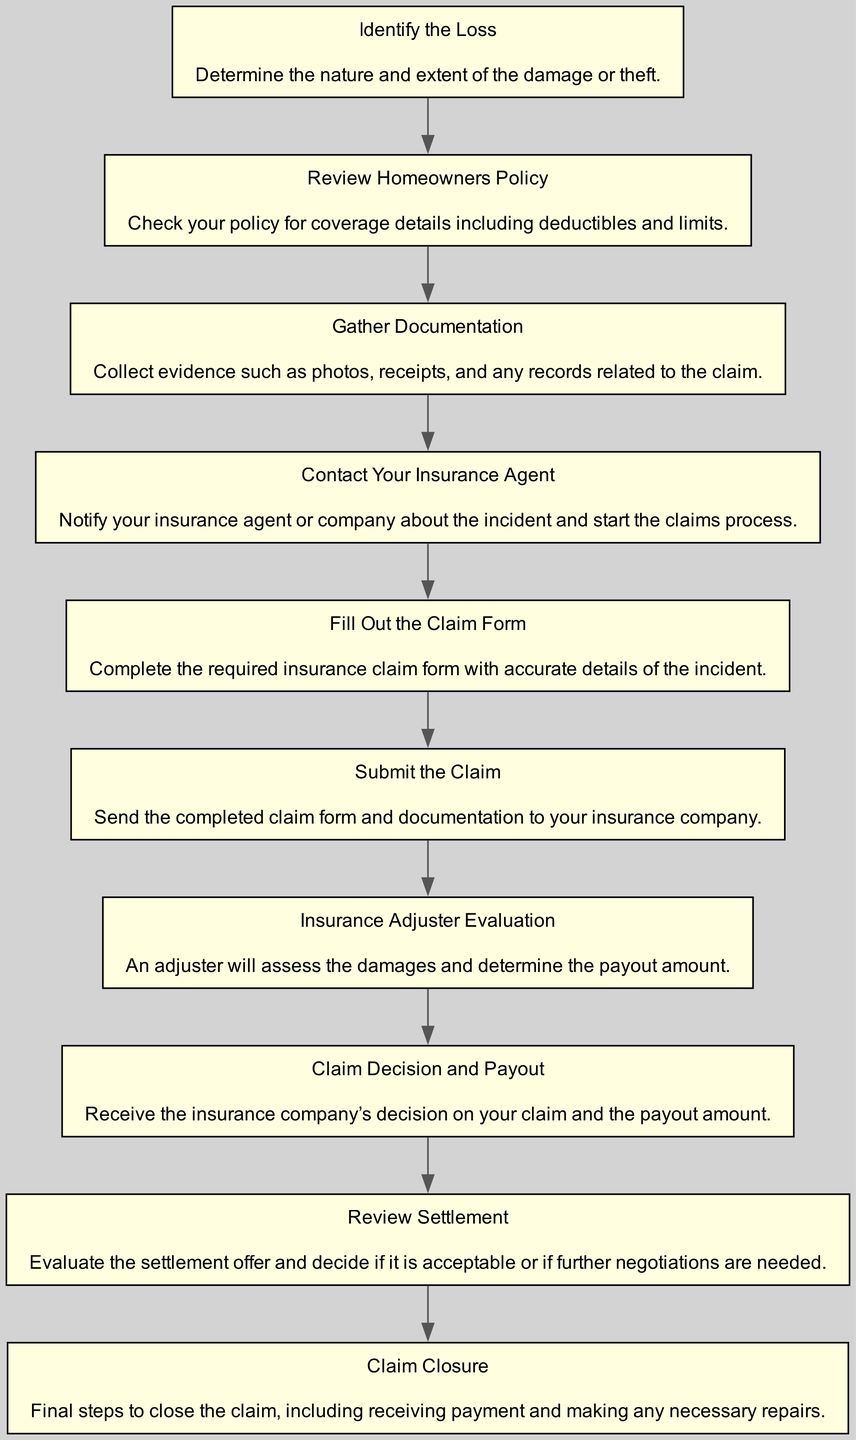What is the first step in the process? The first step in the diagram is "Identify the Loss," which is stated at the top of the flow chart.
Answer: Identify the Loss How many steps are involved in the process? By counting the number of unique nodes in the flow chart, it is clear that there are ten steps involved in the process.
Answer: Ten What comes immediately after "Contact Your Insurance Agent"? Following "Contact Your Insurance Agent" in the flow chart is "Fill Out the Claim Form," which comes directly next in the sequence.
Answer: Fill Out the Claim Form What type of documentation needs to be gathered? The diagram specifies that documentation includes "photos, receipts, and any records related to the claim," presenting these items as necessary evidence in the claims process.
Answer: Photos, receipts, and records What is the final step shown in the diagram? The flow chart concludes with "Claim Closure," which indicates the last action in the claims process.
Answer: Claim Closure What is the decision made after the Insurance Adjuster Evaluation? The decision made following the Insurance Adjuster Evaluation is the "Claim Decision and Payout," which determines the outcome of the claim process.
Answer: Claim Decision and Payout Which step involves communication with the insurance company? The step involving communication with the insurance company is "Contact Your Insurance Agent," where the policyholder notifies the agent about the incident.
Answer: Contact Your Insurance Agent How does one start the claims process? To start the claims process, one must "Contact Your Insurance Agent," which is clearly indicated as the step to initiate communication with the insurance company.
Answer: Contact Your Insurance Agent How are settlement offers assessed? Settlement offers are assessed during the "Review Settlement" step, where the claimant evaluates the proposed offer for acceptance or negotiation.
Answer: Review Settlement 